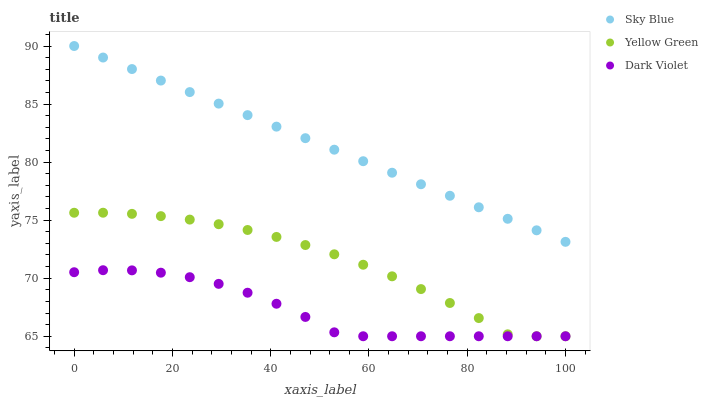Does Dark Violet have the minimum area under the curve?
Answer yes or no. Yes. Does Sky Blue have the maximum area under the curve?
Answer yes or no. Yes. Does Yellow Green have the minimum area under the curve?
Answer yes or no. No. Does Yellow Green have the maximum area under the curve?
Answer yes or no. No. Is Sky Blue the smoothest?
Answer yes or no. Yes. Is Dark Violet the roughest?
Answer yes or no. Yes. Is Yellow Green the smoothest?
Answer yes or no. No. Is Yellow Green the roughest?
Answer yes or no. No. Does Yellow Green have the lowest value?
Answer yes or no. Yes. Does Sky Blue have the highest value?
Answer yes or no. Yes. Does Yellow Green have the highest value?
Answer yes or no. No. Is Yellow Green less than Sky Blue?
Answer yes or no. Yes. Is Sky Blue greater than Yellow Green?
Answer yes or no. Yes. Does Yellow Green intersect Dark Violet?
Answer yes or no. Yes. Is Yellow Green less than Dark Violet?
Answer yes or no. No. Is Yellow Green greater than Dark Violet?
Answer yes or no. No. Does Yellow Green intersect Sky Blue?
Answer yes or no. No. 